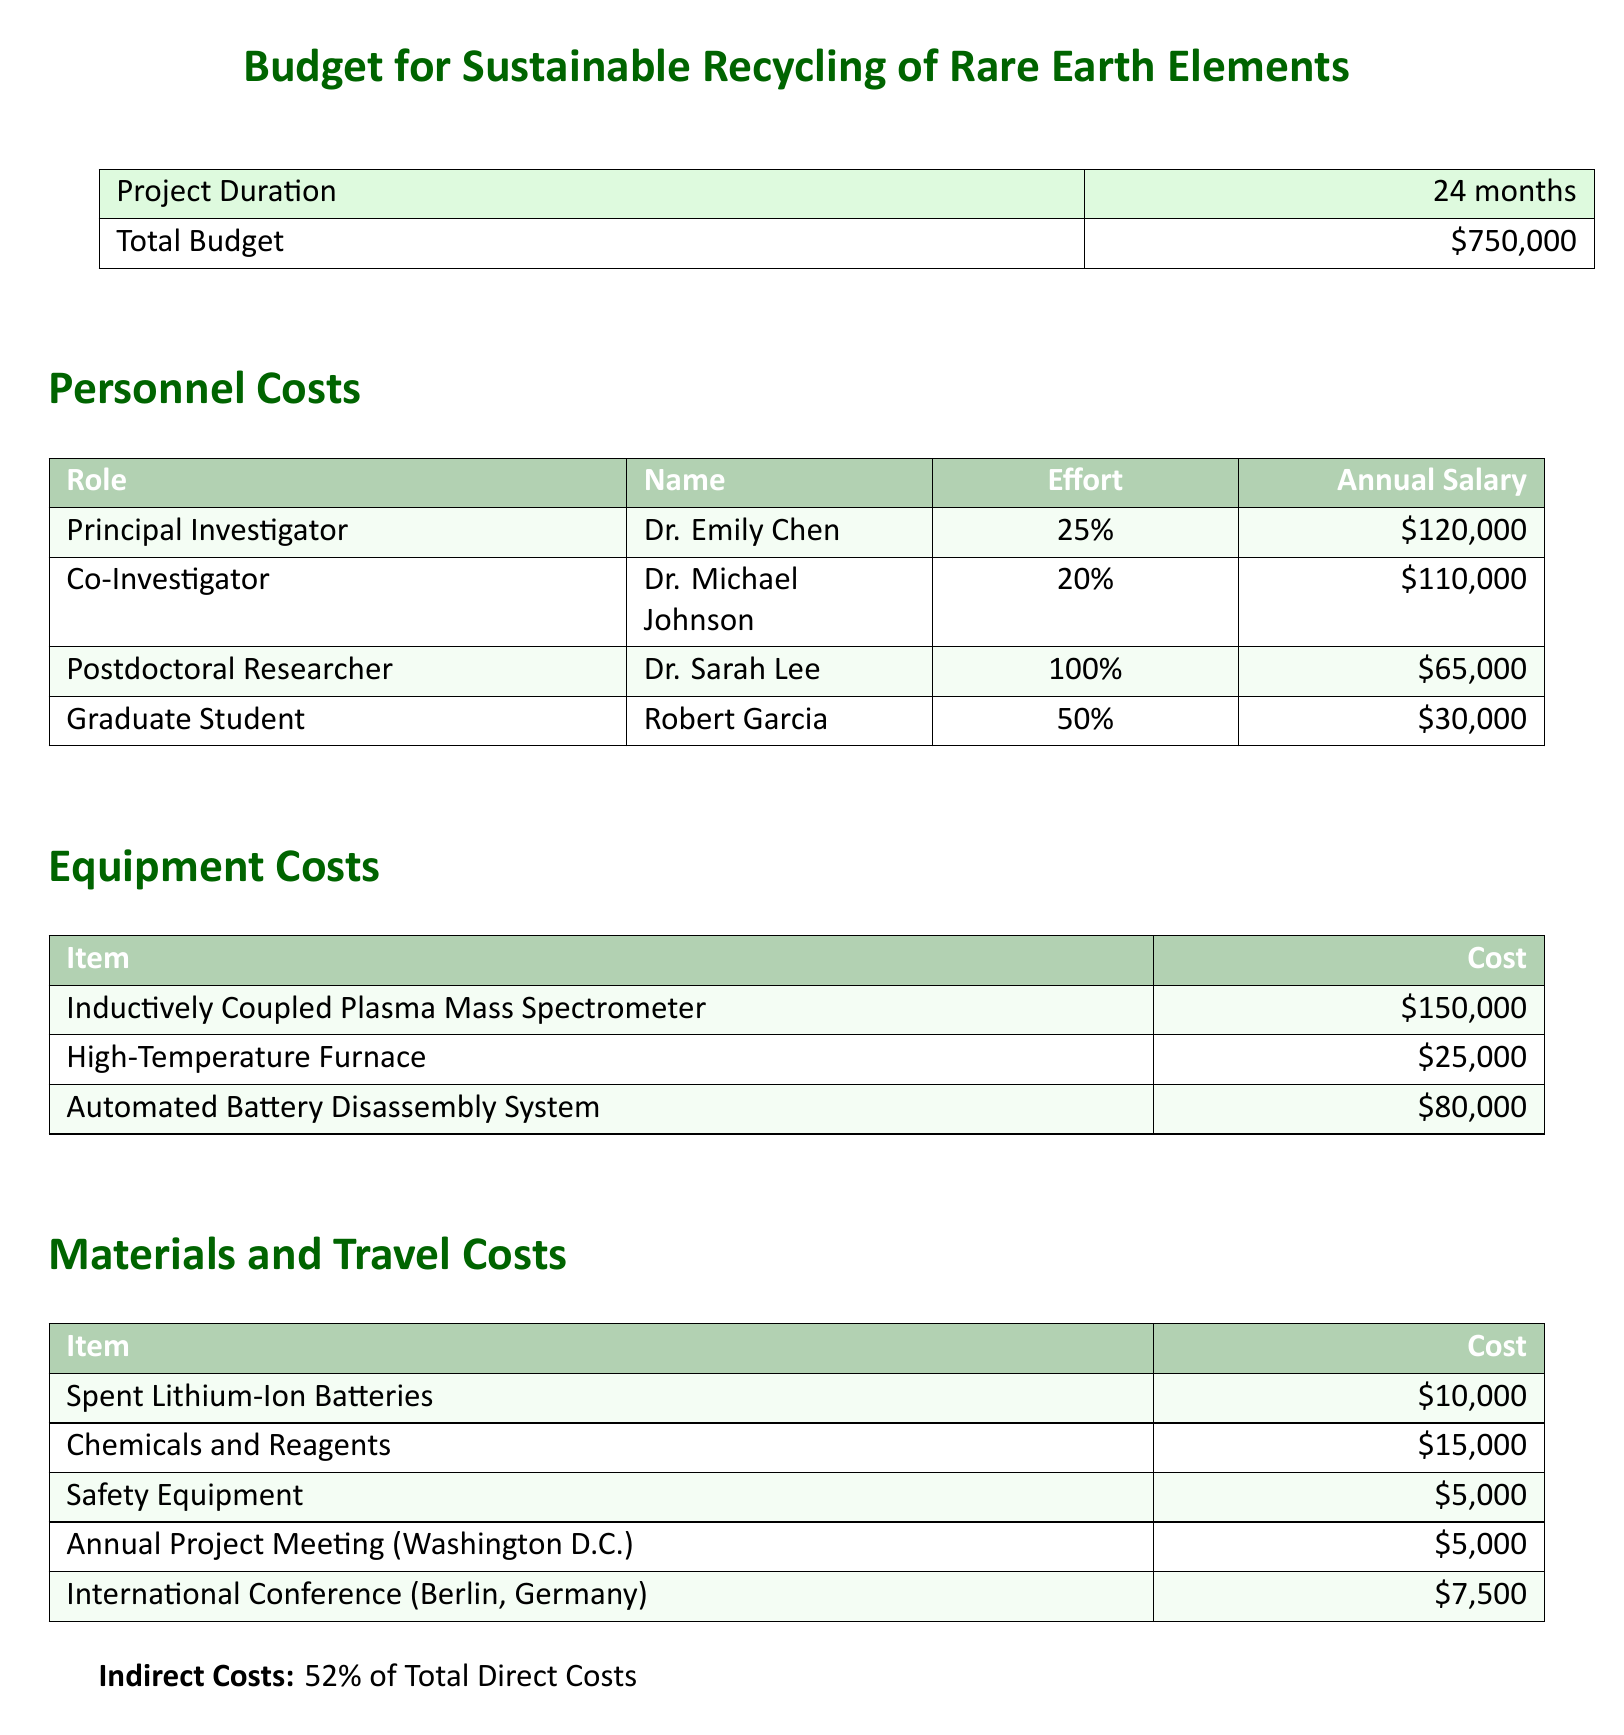What is the total budget? The total budget for the project is specified in the document as $750,000.
Answer: $750,000 Who is the principal investigator? The document lists Dr. Emily Chen as the principal investigator under personnel costs.
Answer: Dr. Emily Chen What is the annual salary of the graduate student? The annual salary for the graduate student is provided in the personnel section as $30,000.
Answer: $30,000 How much does the Inductively Coupled Plasma Mass Spectrometer cost? The equipment section specifies the cost of the Inductively Coupled Plasma Mass Spectrometer as $150,000.
Answer: $150,000 What percentage of total direct costs are indirect costs? The document states that indirect costs are 52% of total direct costs.
Answer: 52% How long is the project duration? The project duration is indicated in the document as 24 months.
Answer: 24 months What is the cost for the international conference in Berlin? The document shows that the cost for the international conference in Berlin, Germany is $7,500.
Answer: $7,500 Who is the co-investigator? The document identifies Dr. Michael Johnson as the co-investigator in the personnel section.
Answer: Dr. Michael Johnson What is the total cost of materials listed? The total for the materials listed is calculated as $10,000 + $15,000 + $5,000 + $5,000 + $7,500 = $42,500.
Answer: $42,500 